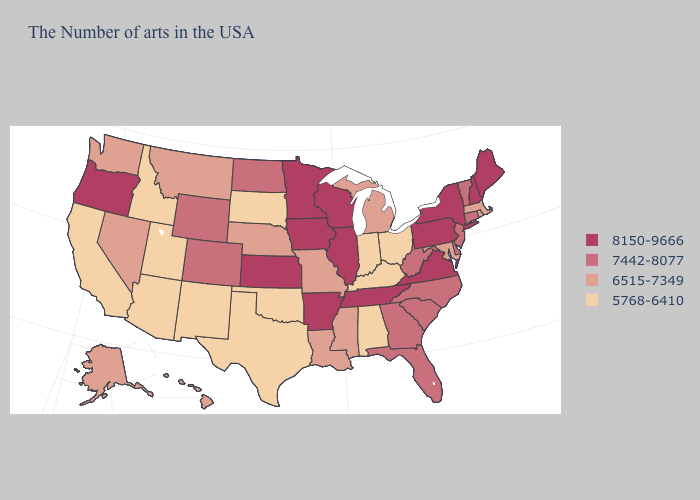Does the map have missing data?
Quick response, please. No. Among the states that border Kansas , which have the highest value?
Concise answer only. Colorado. What is the value of Ohio?
Be succinct. 5768-6410. Does New York have the lowest value in the USA?
Concise answer only. No. What is the value of Idaho?
Answer briefly. 5768-6410. Does North Carolina have the same value as Wyoming?
Write a very short answer. Yes. Name the states that have a value in the range 5768-6410?
Quick response, please. Ohio, Kentucky, Indiana, Alabama, Oklahoma, Texas, South Dakota, New Mexico, Utah, Arizona, Idaho, California. What is the value of Pennsylvania?
Answer briefly. 8150-9666. Among the states that border West Virginia , which have the lowest value?
Be succinct. Ohio, Kentucky. What is the value of Virginia?
Keep it brief. 8150-9666. Name the states that have a value in the range 7442-8077?
Keep it brief. Vermont, Connecticut, New Jersey, Delaware, North Carolina, South Carolina, West Virginia, Florida, Georgia, North Dakota, Wyoming, Colorado. What is the value of Utah?
Quick response, please. 5768-6410. What is the value of Maine?
Answer briefly. 8150-9666. What is the value of North Dakota?
Short answer required. 7442-8077. What is the highest value in states that border Vermont?
Quick response, please. 8150-9666. 